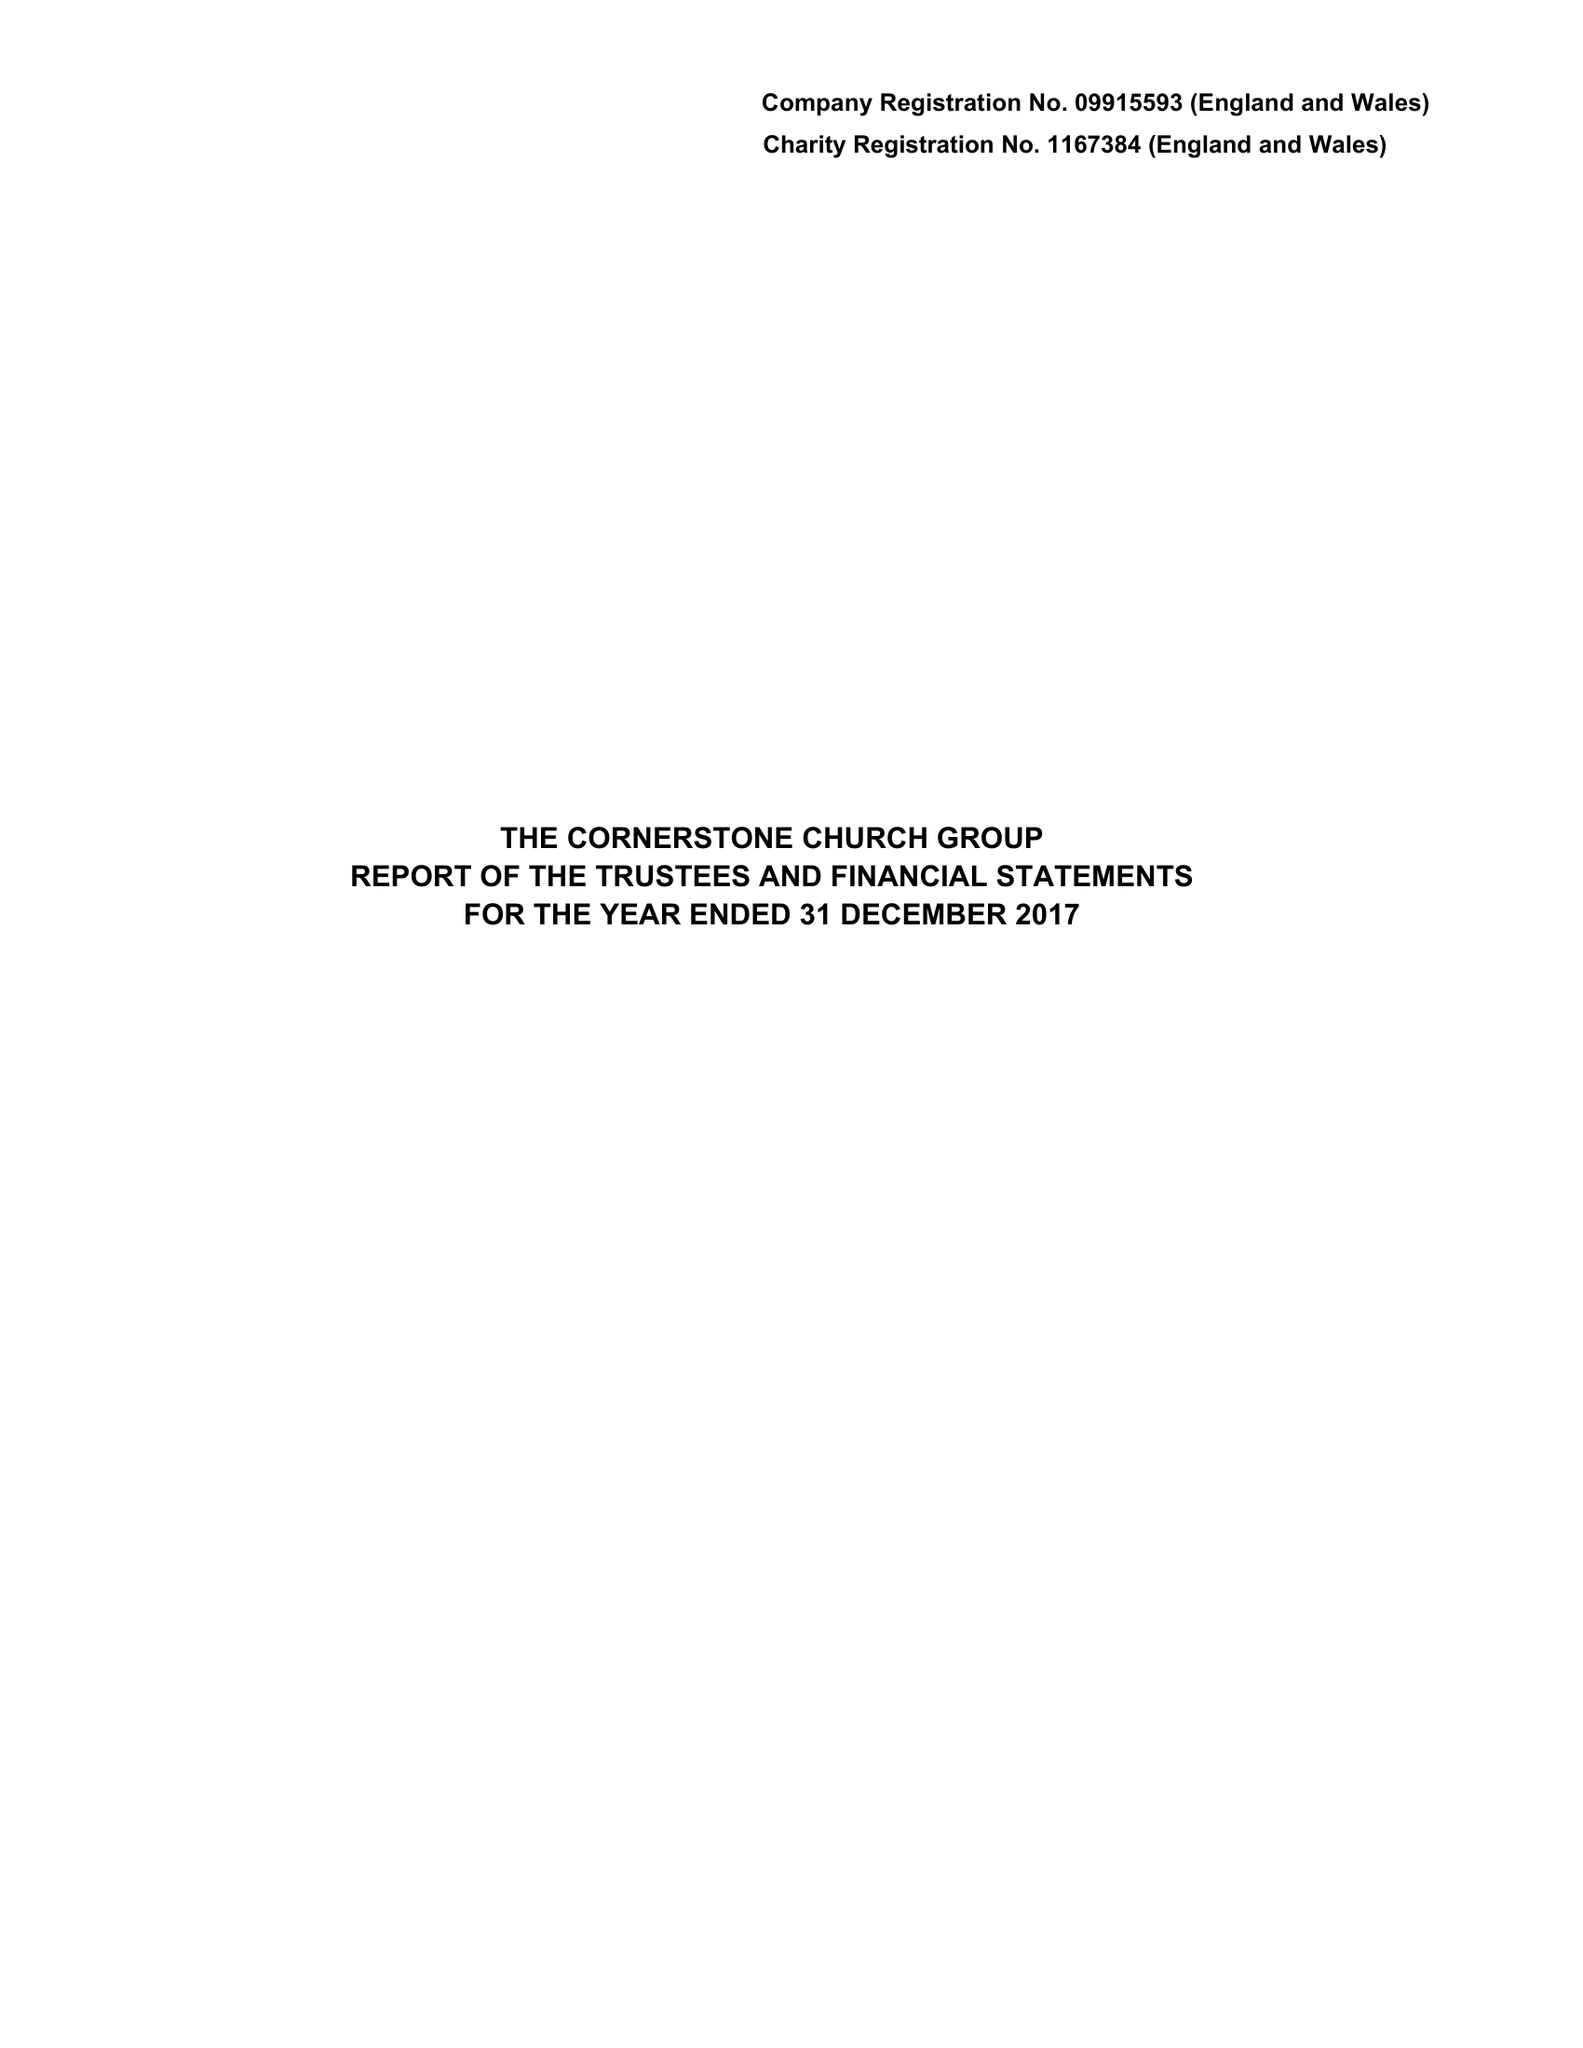What is the value for the address__postcode?
Answer the question using a single word or phrase. EC2A 4NE 